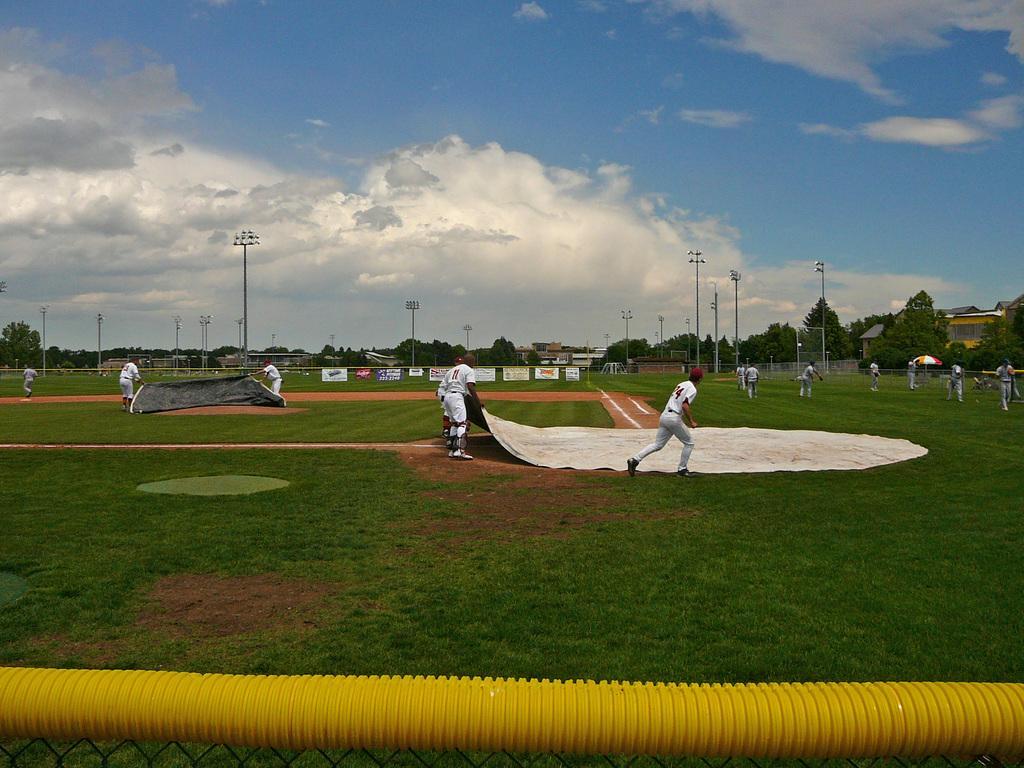In one or two sentences, can you explain what this image depicts? In the center of the image we can see players holding field covers. On the right and left side of the image we can see players on the ground. In the background we can see an advertisements, lights, poles, trees, building, sky and clouds. At the bottom of the image we can see fencing and pipe. 